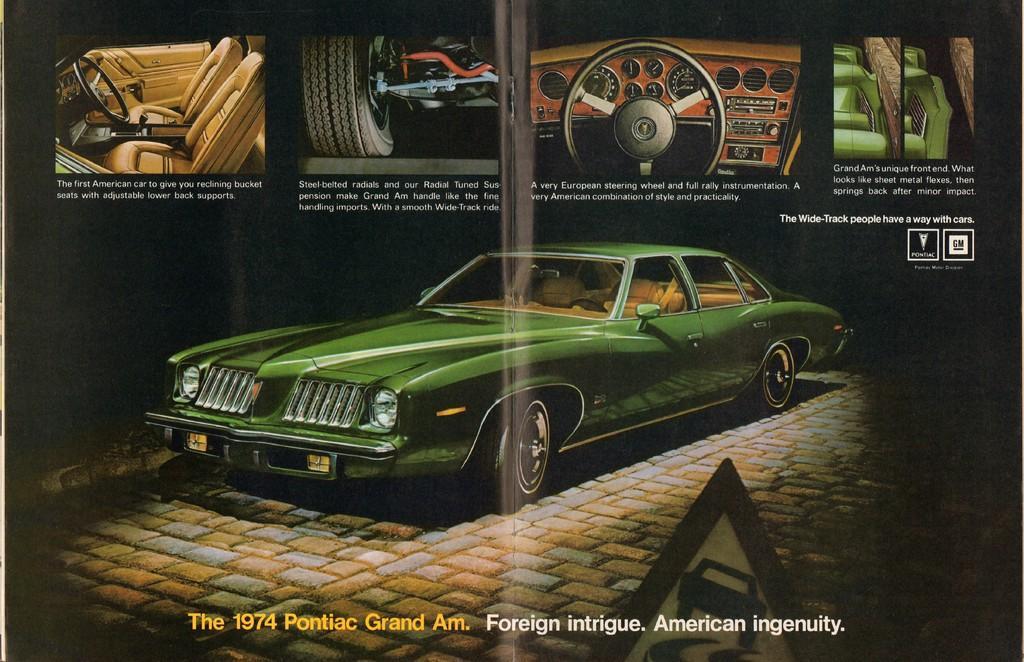Describe this image in one or two sentences. In this picture we can see poster, on this poster we can see a car, steerings, seats, wheel and text. 